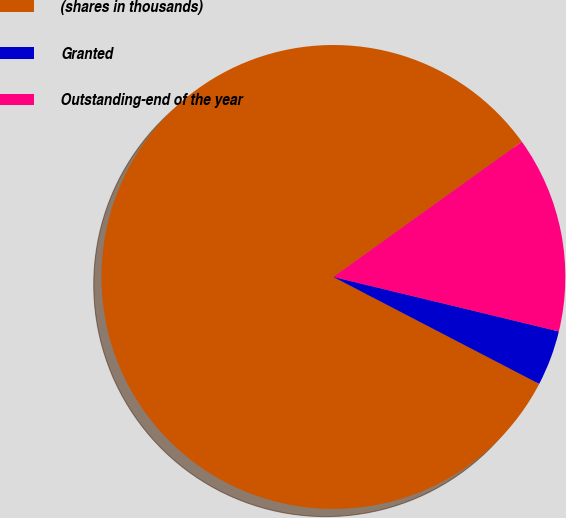Convert chart to OTSL. <chart><loc_0><loc_0><loc_500><loc_500><pie_chart><fcel>(shares in thousands)<fcel>Granted<fcel>Outstanding-end of the year<nl><fcel>82.47%<fcel>3.85%<fcel>13.68%<nl></chart> 